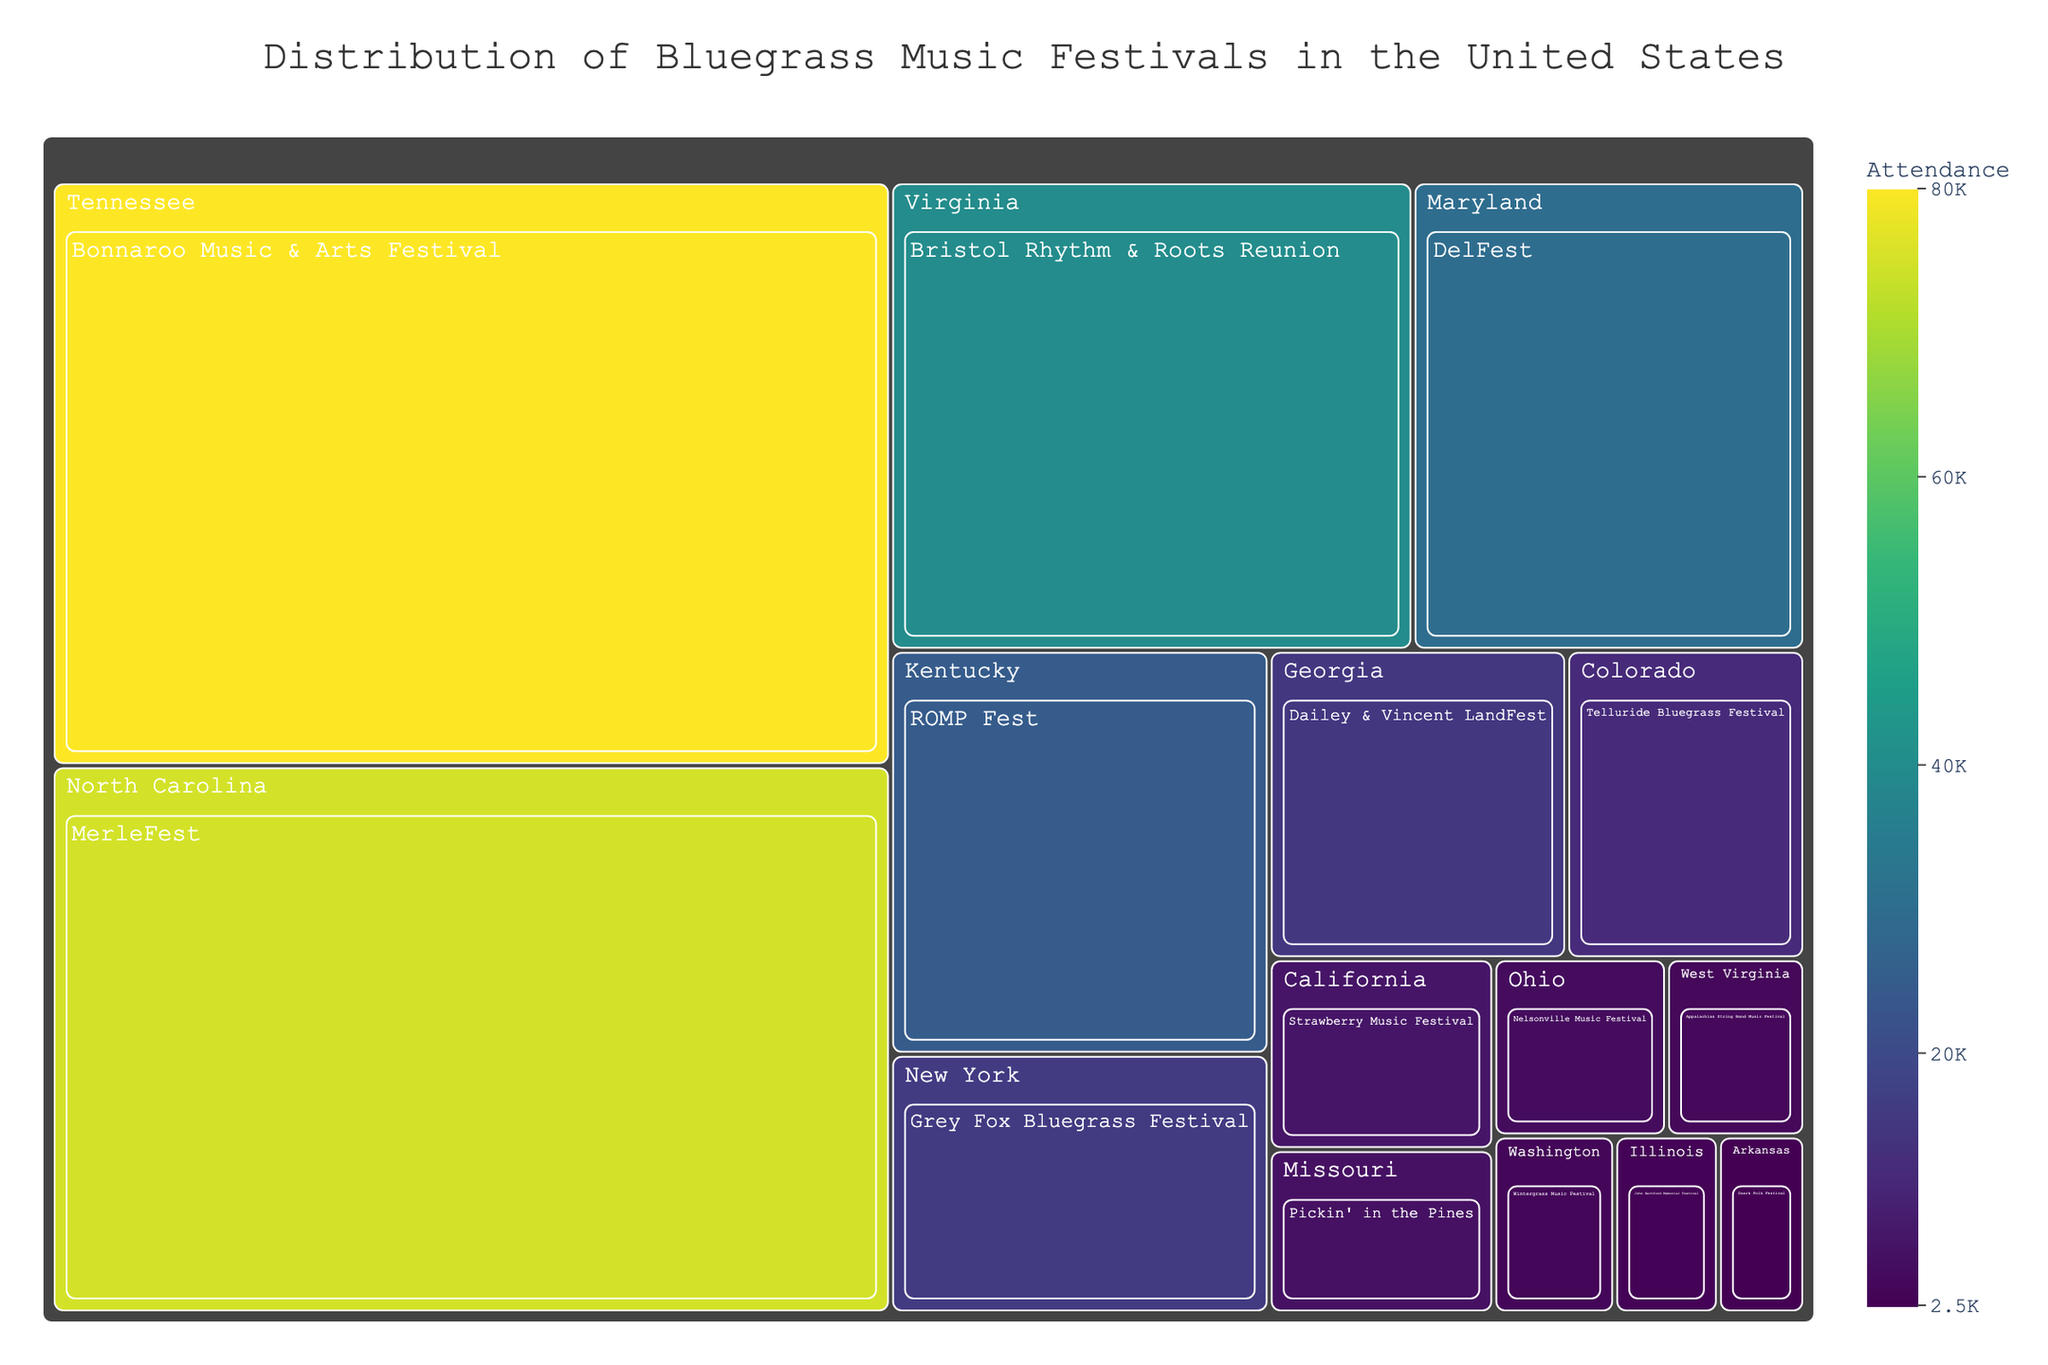Which state hosts the festival with the largest attendance? By examining the size and color of the sections in the treemap, the largest attendance is associated with the darkest and largest segment. Tennessee hosts the Bonnaroo Music & Arts Festival, which has an attendance of 80,000.
Answer: Tennessee Which festival in Virginia has an attendance of 40,000? By identifying the block within Virginia on the treemap, we can see that the Bristol Rhythm & Roots Reunion festival is labeled with an attendance of 40,000.
Answer: Bristol Rhythm & Roots Reunion How many festivals have an attendance greater than 30,000? Observing the individual blocks and their labeled values, Bonnaroo Music & Arts Festival (80,000), MerleFest (75,000), Bristol Rhythm & Roots Reunion (40,000), and DelFest (30,000) are the ones with attendance greater than 30,000.
Answer: Four Which state has the smallest festival attendance, and what is the attendance number? By identifying the smallest and lightest section in the treemap, Arkansas hosts the Ozark Folk Festival with the smallest attendance of 2,500.
Answer: Arkansas, 2,500 Compare the festival attendance between North Carolina and California. Which state has a higher attendance overall and by how much? North Carolina's MerleFest has an attendance of 75,000, while California's Strawberry Music Festival has an attendance of 7,000. The difference is 75,000 - 7,000 = 68,000. North Carolina has 68,000 more attendees than California.
Answer: North Carolina by 68,000 What is the total attendance for festivals across all states listed? Summing up the attendance values: 80,000 + 25,000 + 12,000 + 75,000 + 40,000 + 7,000 + 15,000 + 5,000 + 3,000 + 4,000 + 16,000 + 30,000 + 2,500 + 6,000 + 3,500 = 324,000.
Answer: 324,000 Which festival color appears most frequently in the treemap, and what does this color represent in terms of attendance? The treemap uses a color gradient representing attendance levels. Most sections are in shades of green, indicating attendance levels are often moderate. The color is not explicitly named but is visually associated with moderate attendance categories.
Answer: Modest green, moderate attendance What are the average and median attendance values for the listed festivals? Calculating the average: (80,000 + 25,000 + 12,000 + 75,000 + 40,000 + 7,000 + 15,000 + 5,000 + 3,000 + 4,000 + 16,000 + 30,000 + 2,500 + 6,000 + 3,500)/15 = 324,000/15 = 21,600. For the median, sorting the values: 2,500, 3,000, 3,500, 4,000, 5,000, 6,000, 7,000, 12,000, 15,000, 16,000, 25,000, 30,000, 40,000, 75,000, 80,000 reveals the middle value is 12,000.
Answer: Average: 21,600, Median: 12,000 Which states have only one festival listed in the treemap? Observing the treemap reveals only one festival per block for Maryland, Arkansas, Missouri, and Washington.
Answer: Maryland, Arkansas, Missouri, Washington How does the attendance for the Telluride Bluegrass Festival in Colorado compare with Dailey & Vincent LandFest in Georgia? Looking at the blocks for these states, Colorado's Telluride Bluegrass Festival has 12,000 attendees whereas Georgia's Dailey & Vincent LandFest has 15,000. Georgia's festival has 3,000 more attendees.
Answer: Georgia by 3,000 